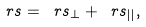<formula> <loc_0><loc_0><loc_500><loc_500>\ r s = \ r s _ { \bot } + \ r s _ { | | } ,</formula> 